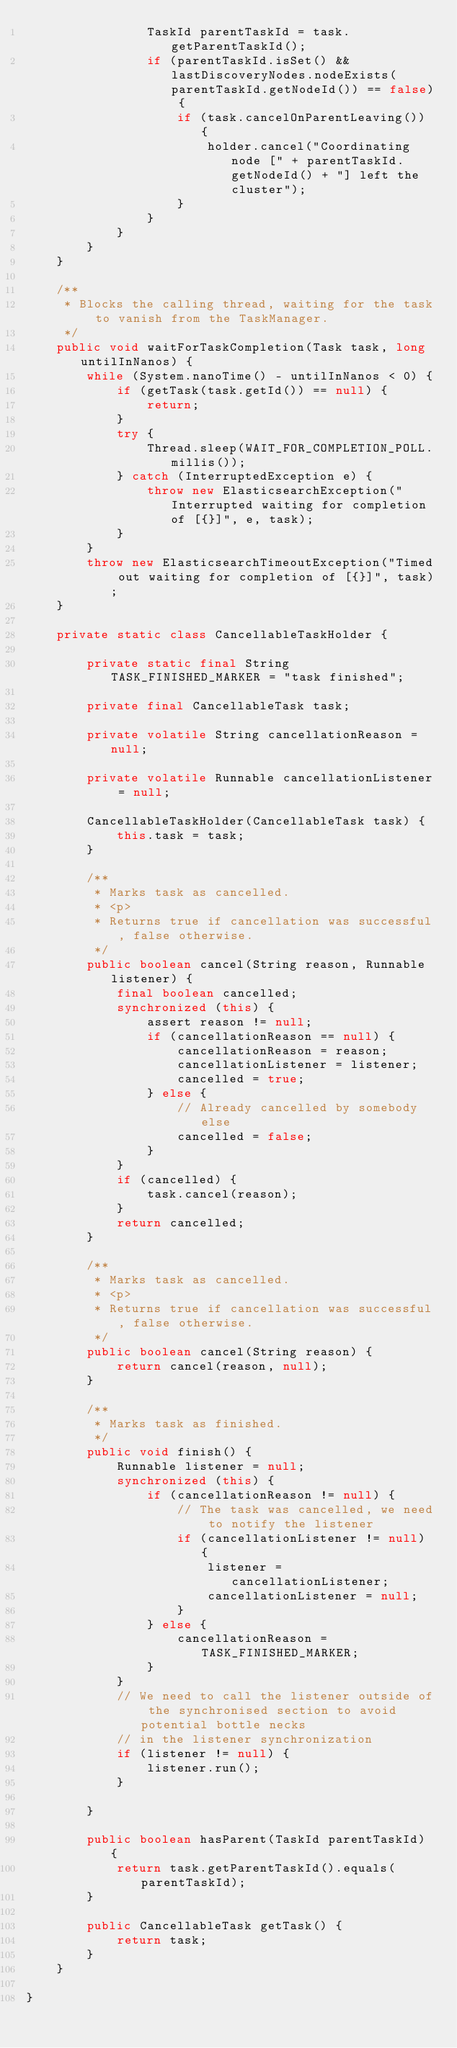<code> <loc_0><loc_0><loc_500><loc_500><_Java_>                TaskId parentTaskId = task.getParentTaskId();
                if (parentTaskId.isSet() && lastDiscoveryNodes.nodeExists(parentTaskId.getNodeId()) == false) {
                    if (task.cancelOnParentLeaving()) {
                        holder.cancel("Coordinating node [" + parentTaskId.getNodeId() + "] left the cluster");
                    }
                }
            }
        }
    }

    /**
     * Blocks the calling thread, waiting for the task to vanish from the TaskManager.
     */
    public void waitForTaskCompletion(Task task, long untilInNanos) {
        while (System.nanoTime() - untilInNanos < 0) {
            if (getTask(task.getId()) == null) {
                return;
            }
            try {
                Thread.sleep(WAIT_FOR_COMPLETION_POLL.millis());
            } catch (InterruptedException e) {
                throw new ElasticsearchException("Interrupted waiting for completion of [{}]", e, task);
            }
        }
        throw new ElasticsearchTimeoutException("Timed out waiting for completion of [{}]", task);
    }

    private static class CancellableTaskHolder {

        private static final String TASK_FINISHED_MARKER = "task finished";

        private final CancellableTask task;

        private volatile String cancellationReason = null;

        private volatile Runnable cancellationListener = null;

        CancellableTaskHolder(CancellableTask task) {
            this.task = task;
        }

        /**
         * Marks task as cancelled.
         * <p>
         * Returns true if cancellation was successful, false otherwise.
         */
        public boolean cancel(String reason, Runnable listener) {
            final boolean cancelled;
            synchronized (this) {
                assert reason != null;
                if (cancellationReason == null) {
                    cancellationReason = reason;
                    cancellationListener = listener;
                    cancelled = true;
                } else {
                    // Already cancelled by somebody else
                    cancelled = false;
                }
            }
            if (cancelled) {
                task.cancel(reason);
            }
            return cancelled;
        }

        /**
         * Marks task as cancelled.
         * <p>
         * Returns true if cancellation was successful, false otherwise.
         */
        public boolean cancel(String reason) {
            return cancel(reason, null);
        }

        /**
         * Marks task as finished.
         */
        public void finish() {
            Runnable listener = null;
            synchronized (this) {
                if (cancellationReason != null) {
                    // The task was cancelled, we need to notify the listener
                    if (cancellationListener != null) {
                        listener = cancellationListener;
                        cancellationListener = null;
                    }
                } else {
                    cancellationReason = TASK_FINISHED_MARKER;
                }
            }
            // We need to call the listener outside of the synchronised section to avoid potential bottle necks
            // in the listener synchronization
            if (listener != null) {
                listener.run();
            }

        }

        public boolean hasParent(TaskId parentTaskId) {
            return task.getParentTaskId().equals(parentTaskId);
        }

        public CancellableTask getTask() {
            return task;
        }
    }

}
</code> 